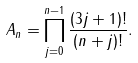<formula> <loc_0><loc_0><loc_500><loc_500>A _ { n } = \prod _ { j = 0 } ^ { n - 1 } \frac { ( 3 j + 1 ) ! } { ( n + j ) ! } .</formula> 